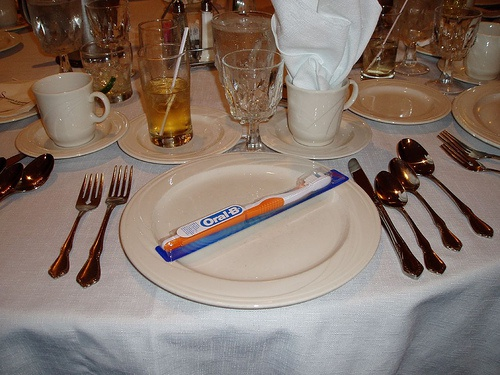Describe the objects in this image and their specific colors. I can see dining table in black, darkgray, and gray tones, cup in black, maroon, olive, and gray tones, wine glass in black, gray, brown, and maroon tones, cup in black, gray, and darkgray tones, and cup in black, darkgray, and gray tones in this image. 